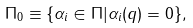Convert formula to latex. <formula><loc_0><loc_0><loc_500><loc_500>\Pi _ { 0 } \equiv \{ \alpha _ { i } \in \Pi | \alpha _ { i } ( q ) = 0 \} ,</formula> 